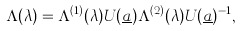<formula> <loc_0><loc_0><loc_500><loc_500>\Lambda ( \lambda ) = \Lambda ^ { ( 1 ) } ( \lambda ) U ( \underline { a } ) \Lambda ^ { ( 2 ) } ( \lambda ) U ( \underline { a } ) ^ { - 1 } ,</formula> 